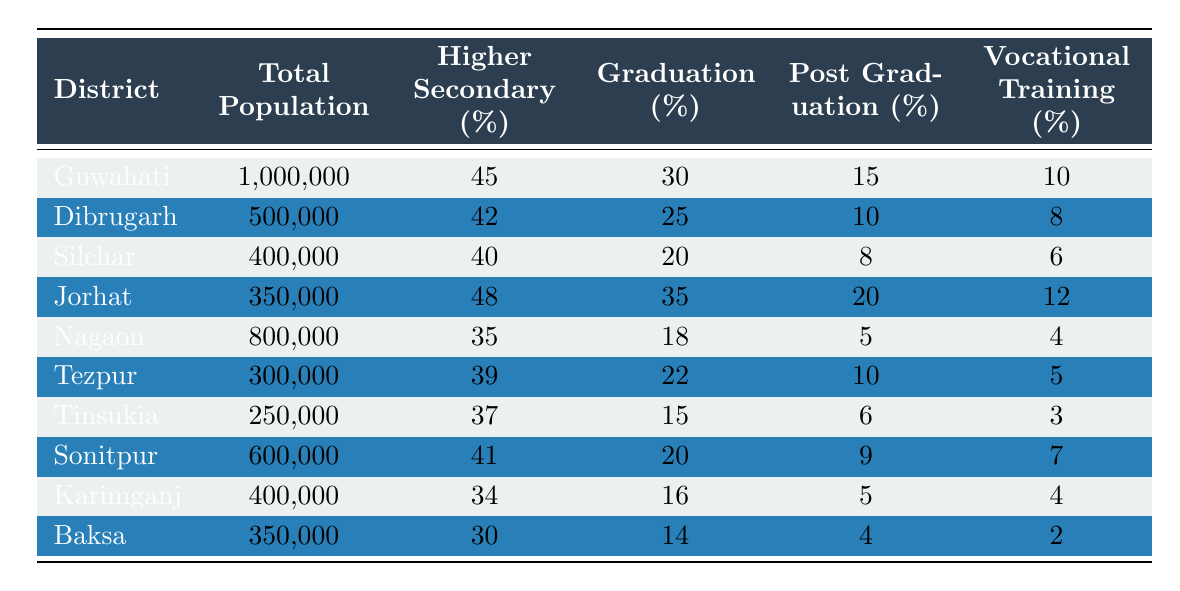What is the total population of Guwahati? The table shows that the total population of Guwahati is listed under the "Total Population" column, which is 1,000,000.
Answer: 1,000,000 Which district has the highest percentage of Higher Secondary education attainment? By comparing the values in the "Higher Secondary (%)" column, Jorhat has the highest percentage at 48%.
Answer: Jorhat What is the percentage of Graduation attainment in Silchar? The table indicates that the "Graduation (%)" for Silchar is 20%.
Answer: 20% Calculate the average percentage of Post Graduation attainment across all districts. The sum of Post Graduation percentages is (15 + 10 + 8 + 20 + 5 + 10 + 6 + 9 + 5 + 4) = 92. There are 10 districts, so the average is 92/10 = 9.2%.
Answer: 9.2% Is the percentage of Vocational Training higher in Dibrugarh than in Nagaon? Looking at the "Vocational Training (%)" column, Dibrugarh has 8% while Nagaon has 4%, indicating that Dibrugarh has a higher percentage.
Answer: Yes Which district has the lowest percentage of Graduation attainment? Reviewing the "Graduation (%)" column, Baksa has the lowest percentage at 14%.
Answer: Baksa What is the difference in percentage of Higher Secondary attainment between Guwahati and Nagaon? Guwahati's Higher Secondary percentage is 45%, and Nagaon's is 35%. The difference is 45% - 35% = 10%.
Answer: 10% If we compare total populations, which district has a total population closest to 300,000? Looking at the "Total Population" column, Tezpur is exactly 300,000, which matches the query.
Answer: Tezpur What percentage of the population in Jorhat has either Graduation or Post Graduation attainment? Jorhat has 35% Graduation and 20% Post Graduation. The combined percentage is 35% + 20% = 55%.
Answer: 55% Which district has a higher percentage of Vocational Training, Sonitpur or Tinsukia? The table indicates that Sonitpur has 7% and Tinsukia has 3%. Thus, Sonitpur has a higher percentage of Vocational Training.
Answer: Sonitpur 